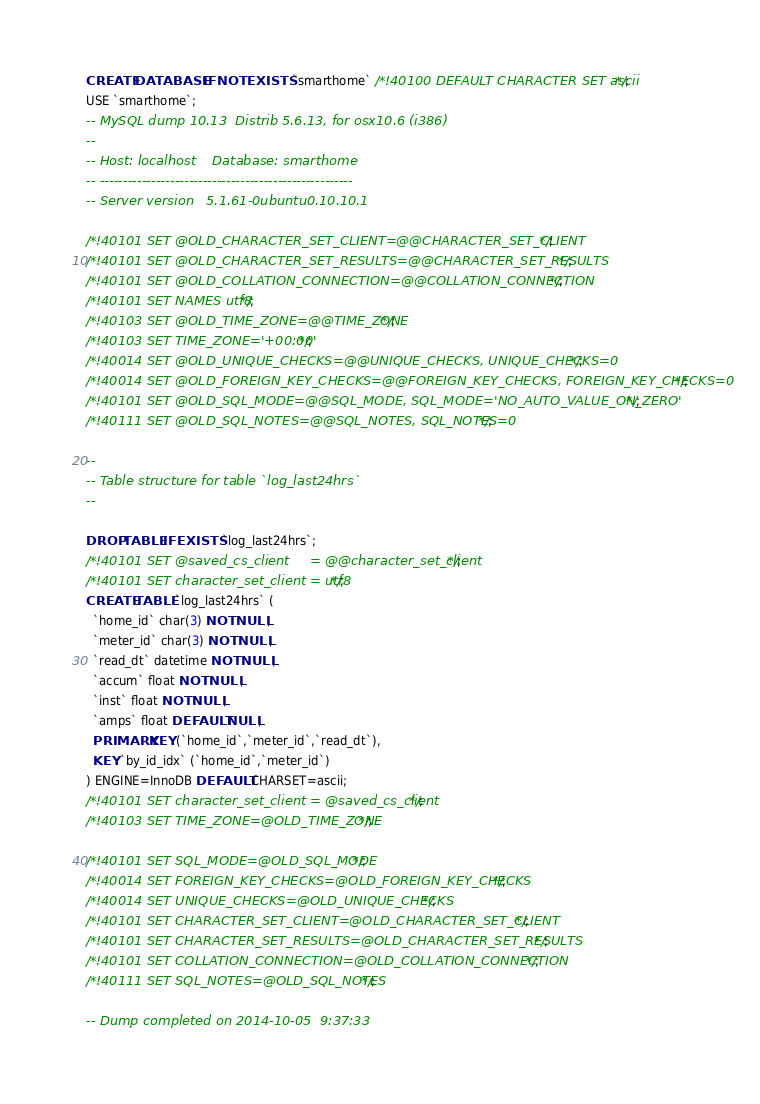<code> <loc_0><loc_0><loc_500><loc_500><_SQL_>CREATE DATABASE  IF NOT EXISTS `smarthome` /*!40100 DEFAULT CHARACTER SET ascii */;
USE `smarthome`;
-- MySQL dump 10.13  Distrib 5.6.13, for osx10.6 (i386)
--
-- Host: localhost    Database: smarthome
-- ------------------------------------------------------
-- Server version	5.1.61-0ubuntu0.10.10.1

/*!40101 SET @OLD_CHARACTER_SET_CLIENT=@@CHARACTER_SET_CLIENT */;
/*!40101 SET @OLD_CHARACTER_SET_RESULTS=@@CHARACTER_SET_RESULTS */;
/*!40101 SET @OLD_COLLATION_CONNECTION=@@COLLATION_CONNECTION */;
/*!40101 SET NAMES utf8 */;
/*!40103 SET @OLD_TIME_ZONE=@@TIME_ZONE */;
/*!40103 SET TIME_ZONE='+00:00' */;
/*!40014 SET @OLD_UNIQUE_CHECKS=@@UNIQUE_CHECKS, UNIQUE_CHECKS=0 */;
/*!40014 SET @OLD_FOREIGN_KEY_CHECKS=@@FOREIGN_KEY_CHECKS, FOREIGN_KEY_CHECKS=0 */;
/*!40101 SET @OLD_SQL_MODE=@@SQL_MODE, SQL_MODE='NO_AUTO_VALUE_ON_ZERO' */;
/*!40111 SET @OLD_SQL_NOTES=@@SQL_NOTES, SQL_NOTES=0 */;

--
-- Table structure for table `log_last24hrs`
--

DROP TABLE IF EXISTS `log_last24hrs`;
/*!40101 SET @saved_cs_client     = @@character_set_client */;
/*!40101 SET character_set_client = utf8 */;
CREATE TABLE `log_last24hrs` (
  `home_id` char(3) NOT NULL,
  `meter_id` char(3) NOT NULL,
  `read_dt` datetime NOT NULL,
  `accum` float NOT NULL,
  `inst` float NOT NULL,
  `amps` float DEFAULT NULL,
  PRIMARY KEY (`home_id`,`meter_id`,`read_dt`),
  KEY `by_id_idx` (`home_id`,`meter_id`)
) ENGINE=InnoDB DEFAULT CHARSET=ascii;
/*!40101 SET character_set_client = @saved_cs_client */;
/*!40103 SET TIME_ZONE=@OLD_TIME_ZONE */;

/*!40101 SET SQL_MODE=@OLD_SQL_MODE */;
/*!40014 SET FOREIGN_KEY_CHECKS=@OLD_FOREIGN_KEY_CHECKS */;
/*!40014 SET UNIQUE_CHECKS=@OLD_UNIQUE_CHECKS */;
/*!40101 SET CHARACTER_SET_CLIENT=@OLD_CHARACTER_SET_CLIENT */;
/*!40101 SET CHARACTER_SET_RESULTS=@OLD_CHARACTER_SET_RESULTS */;
/*!40101 SET COLLATION_CONNECTION=@OLD_COLLATION_CONNECTION */;
/*!40111 SET SQL_NOTES=@OLD_SQL_NOTES */;

-- Dump completed on 2014-10-05  9:37:33
</code> 